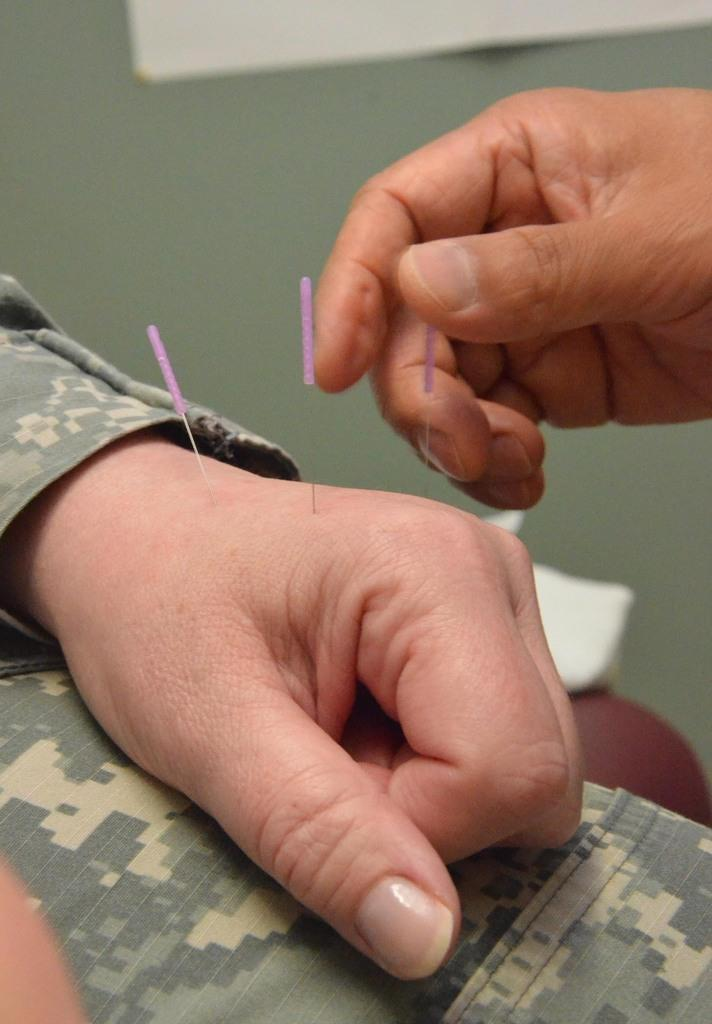What is present on the human hand in the image? There are needles on a human hand in the image. Can you describe the other hand in the image? There is another hand on the right side of the image. What type of question is being asked by the yam in the image? There is no yam present in the image, and therefore no such activity can be observed. 